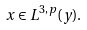<formula> <loc_0><loc_0><loc_500><loc_500>x \in L ^ { 3 , p } ( y ) .</formula> 